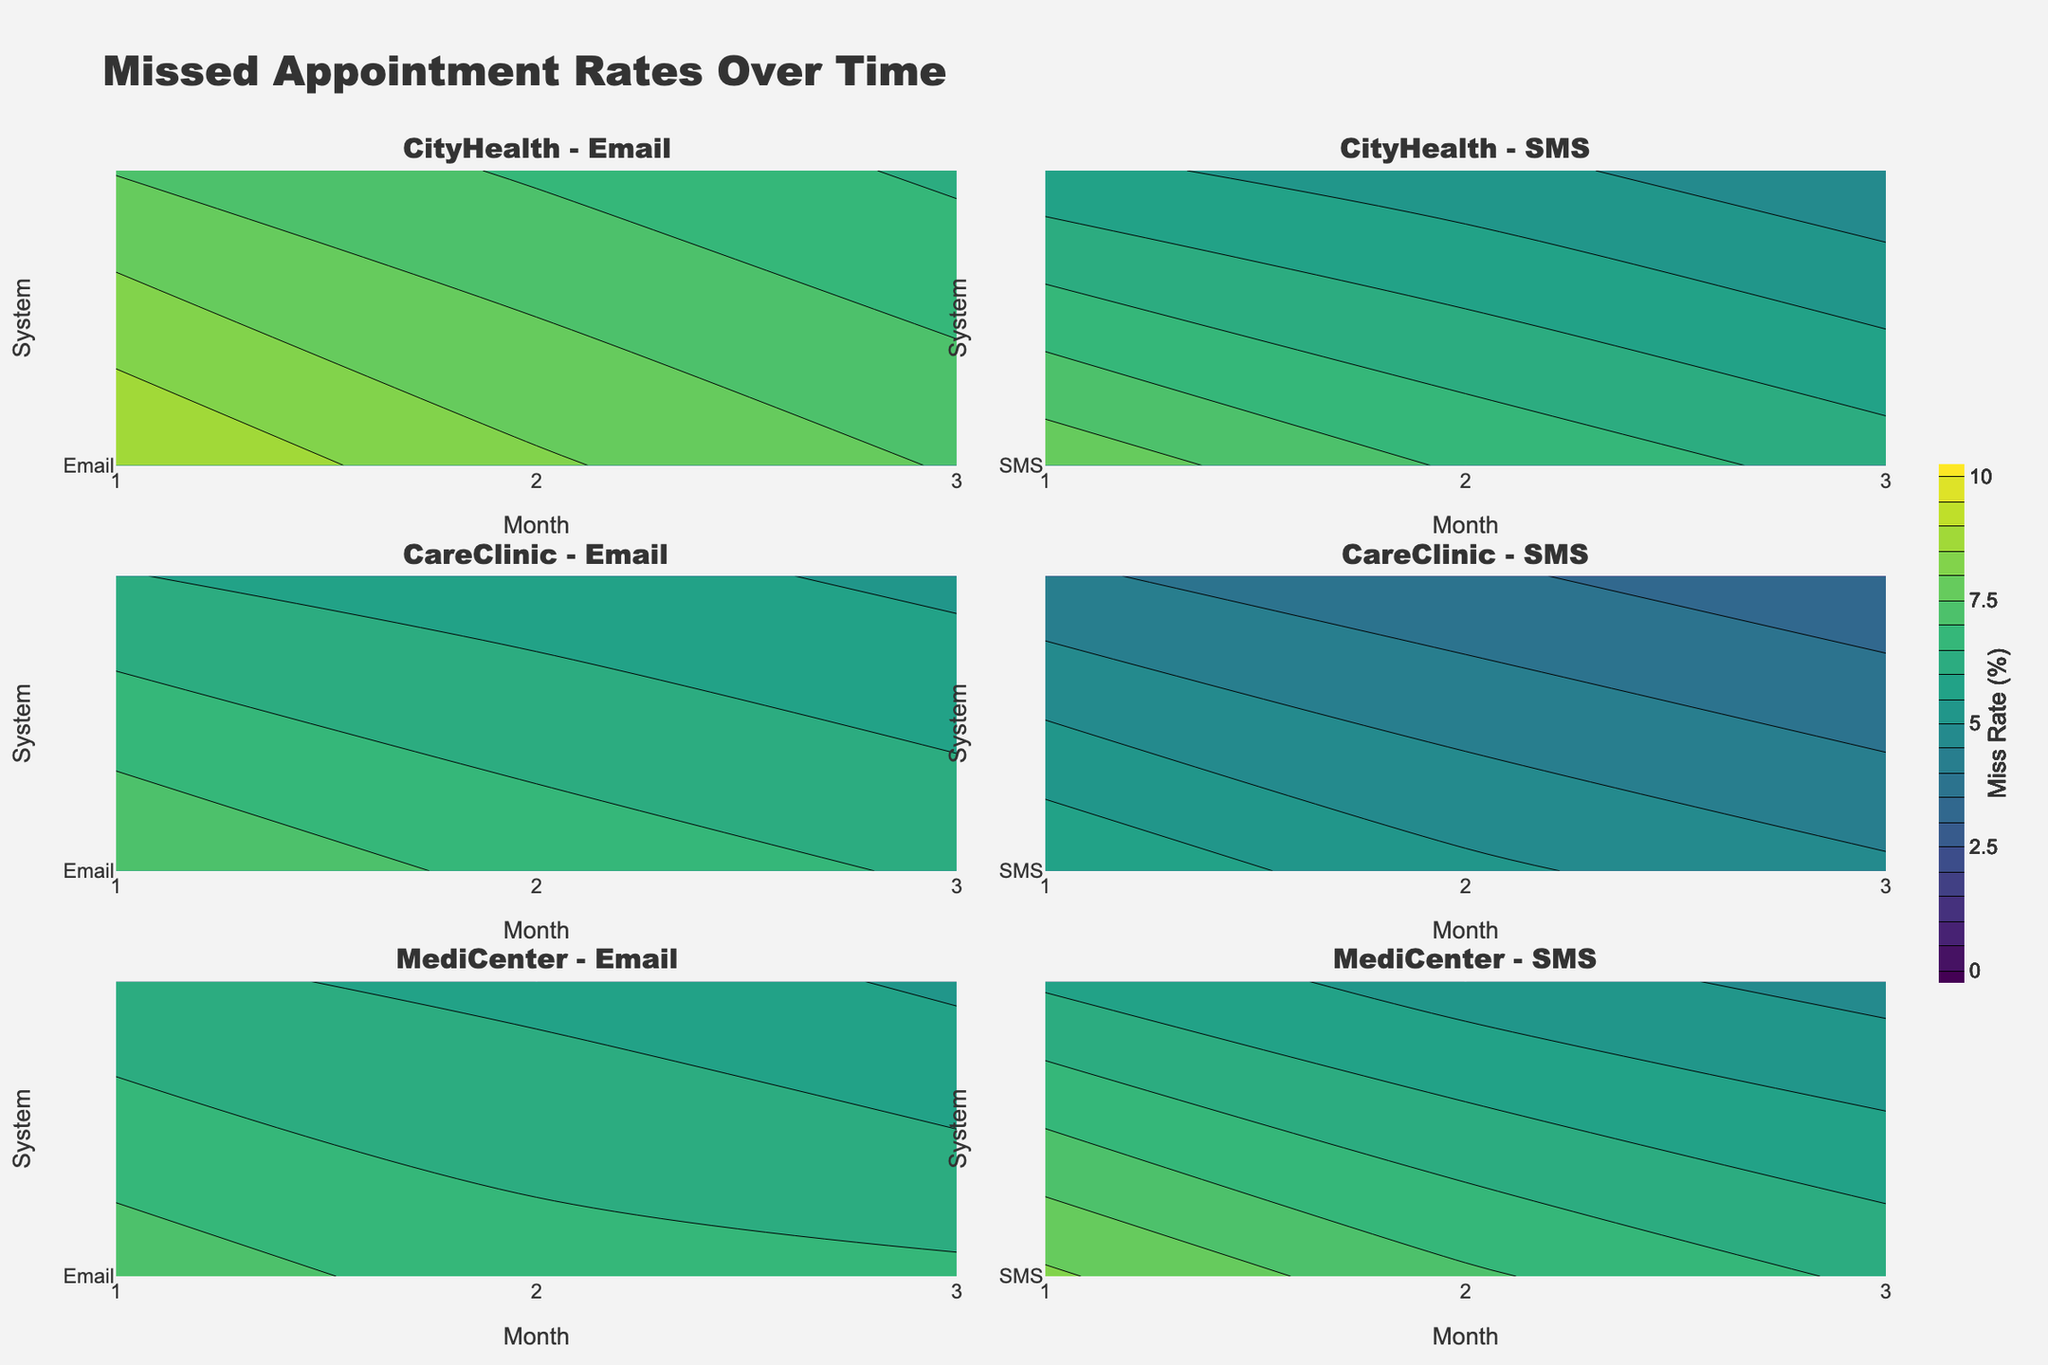What's the title of the figure? Look at the top section of the plot where the main title is usually placed; it should state what the figure represents.
Answer: Missed Appointment Rates Over Time Which clinic has the highest missed appointment rate at the beginning of the period for SMS reminders? Locate the subplot for the first month, identify "SMS" rows, and compare the values.
Answer: MediCenter How does the missed appointment rate change over time for CityHealth with Email reminders? Find the subplot for CityHealth with Email reminders and observe how the contour lines shift from the first month to the sixth month.
Answer: The rate decreases over time Compare the effectiveness of Email vs SMS reminders for CareClinic. Which system is more effective at reducing missed appointments? Locate subplots for CareClinic with both Email and SMS reminders and compare the steepness of contours. The steeper decrease indicates higher effectiveness.
Answer: SMS reminders are more effective Which clinic shows the most significant improvement in missed appointment rates with Email reminders over six months? Find the subplots with Email reminders for all clinics and compare the changes in contour values from the first to the last month
Answer: CareClinic What is the general trend in missed appointment rates over time across all clinics? Observe the overall direction of contour lines across all subplots as you move from the first to the last month.
Answer: The rates generally decrease What can you infer about the relative effectiveness of Email reminders versus SMS reminders across clinics? By comparing corresponding Email and SMS reminder subplots for each clinic, assess which type has fewer contours in the later months.
Answer: SMS reminders are generally more effective In which month do all clinics have the lowest missed appointment rates for SMS reminders? Check the contours for SMS reminders in all clinics and look for the month with the lowest values.
Answer: Month 6 Which clinic starts with a lower missed appointment rate for Email reminders, CityHealth or MediCenter? Compare the first month's contours for Email reminders in CityHealth and MediCenter subplots.
Answer: MediCenter Are there any noticeable color differences between the contours of different reminder systems within the same clinic? Look at the subplots of the same clinic for both Email and SMS reminders and compare the contour colors.
Answer: Yes, there are differences 